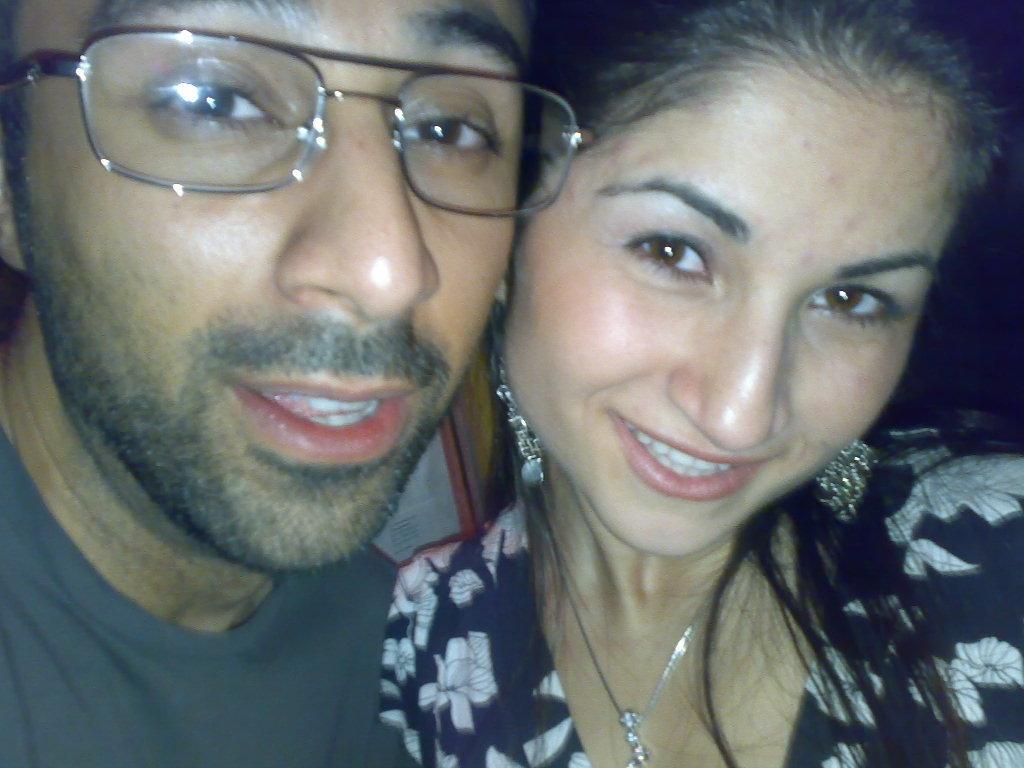In one or two sentences, can you explain what this image depicts? In this picture there is a man with grey t-shirt and spectacles and there is a woman with black and white dress. 